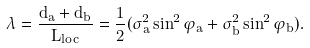<formula> <loc_0><loc_0><loc_500><loc_500>\lambda = \frac { d _ { a } + d _ { b } } { L _ { l o c } } = \frac { 1 } { 2 } ( \sigma _ { a } ^ { 2 } \sin ^ { 2 } \varphi _ { a } + \sigma _ { b } ^ { 2 } \sin ^ { 2 } \varphi _ { b } ) .</formula> 